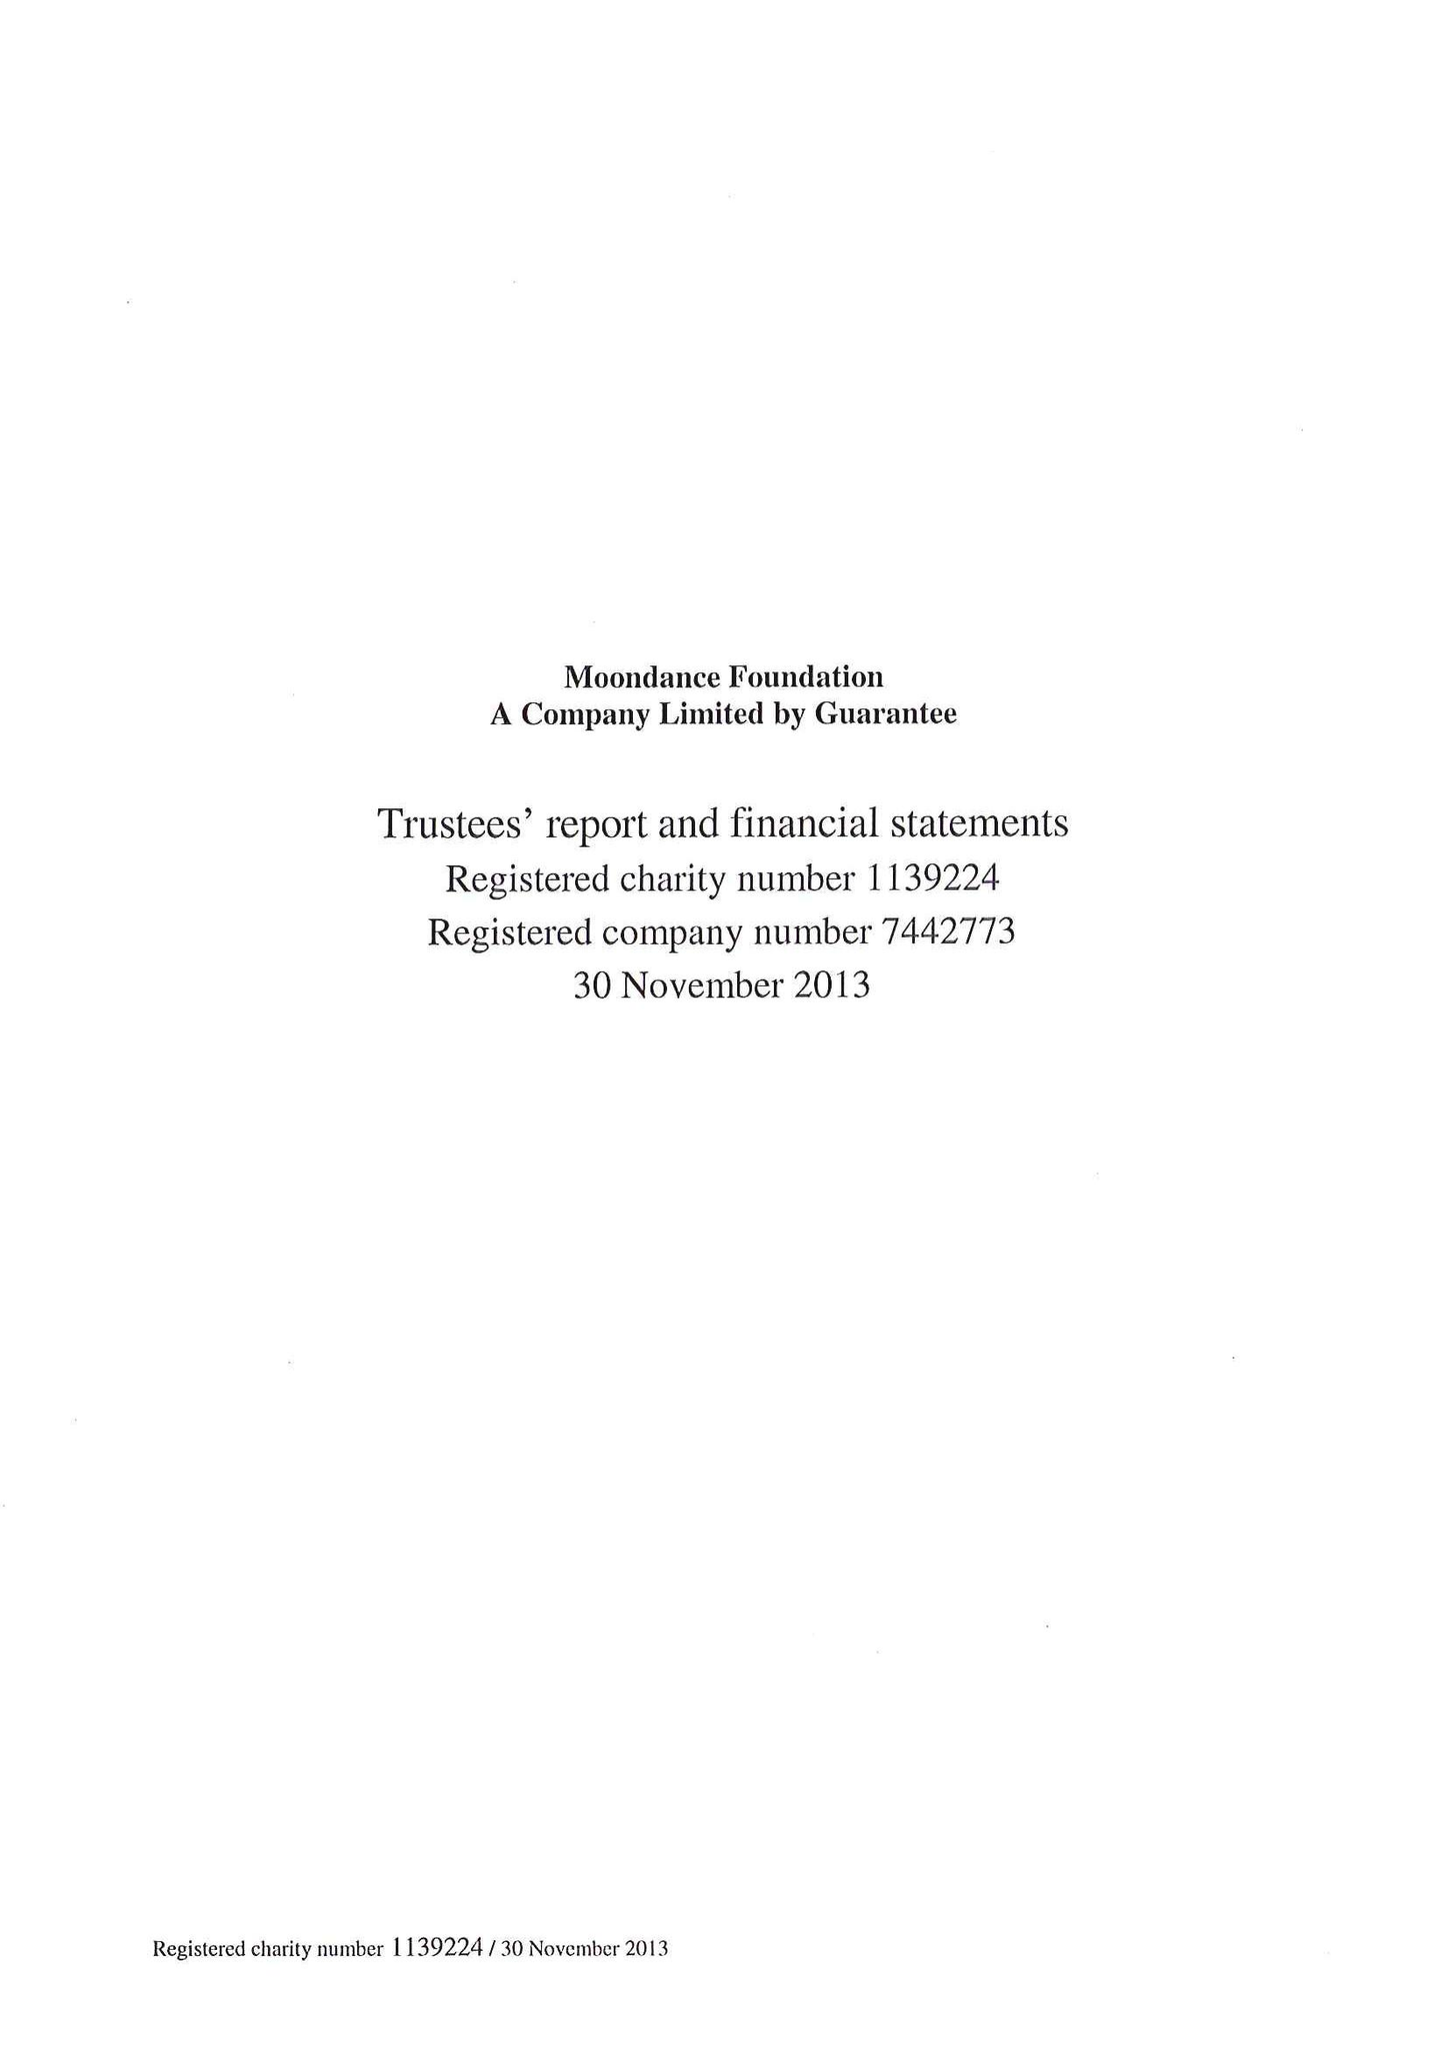What is the value for the charity_name?
Answer the question using a single word or phrase. Moondance Foundation 